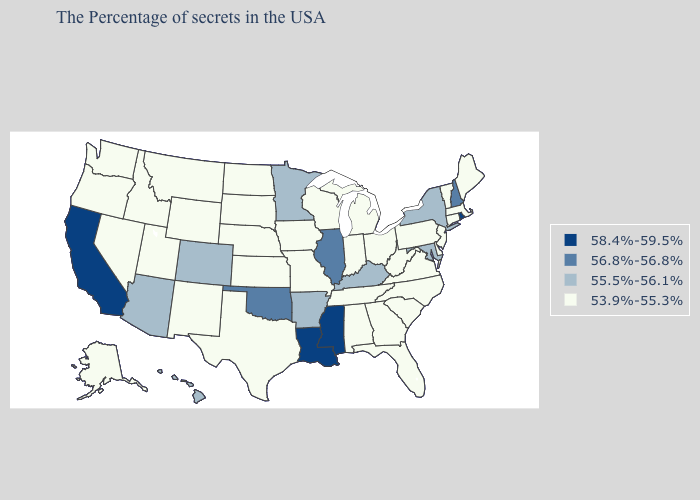Name the states that have a value in the range 56.8%-56.8%?
Write a very short answer. New Hampshire, Illinois, Oklahoma. What is the highest value in states that border Tennessee?
Quick response, please. 58.4%-59.5%. Among the states that border Oklahoma , does Arkansas have the highest value?
Keep it brief. Yes. Does California have the highest value in the USA?
Short answer required. Yes. Is the legend a continuous bar?
Short answer required. No. Does California have the highest value in the USA?
Quick response, please. Yes. Does Alabama have the highest value in the USA?
Concise answer only. No. Which states hav the highest value in the West?
Be succinct. California. How many symbols are there in the legend?
Short answer required. 4. What is the value of Florida?
Concise answer only. 53.9%-55.3%. Does Oklahoma have the lowest value in the USA?
Be succinct. No. Does New Hampshire have the lowest value in the Northeast?
Quick response, please. No. Name the states that have a value in the range 53.9%-55.3%?
Quick response, please. Maine, Massachusetts, Vermont, Connecticut, New Jersey, Delaware, Pennsylvania, Virginia, North Carolina, South Carolina, West Virginia, Ohio, Florida, Georgia, Michigan, Indiana, Alabama, Tennessee, Wisconsin, Missouri, Iowa, Kansas, Nebraska, Texas, South Dakota, North Dakota, Wyoming, New Mexico, Utah, Montana, Idaho, Nevada, Washington, Oregon, Alaska. What is the value of Indiana?
Answer briefly. 53.9%-55.3%. 